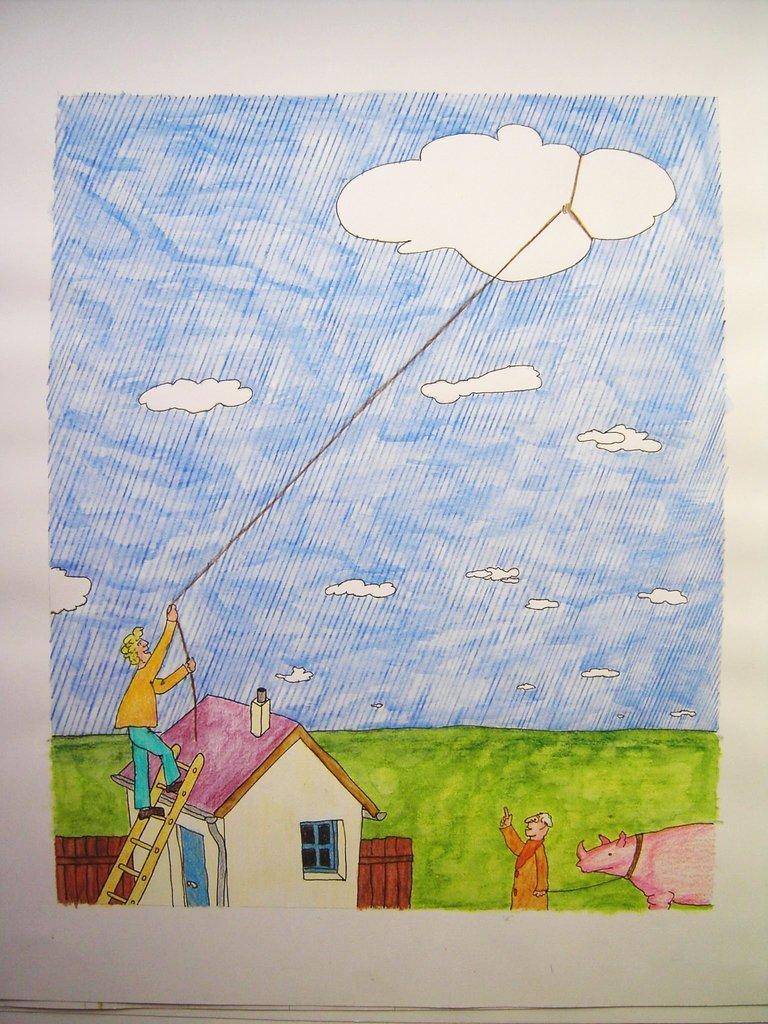Please provide a concise description of this image. In the center of this picture we can see a drawing consists of a house and there is a person climbing a ladder and holding a rope. On the right we can see an animal and a person standing on the ground. In the background we can see the sky with the clouds and we can see a rope is tied to the cloud and we can see the green grass. 